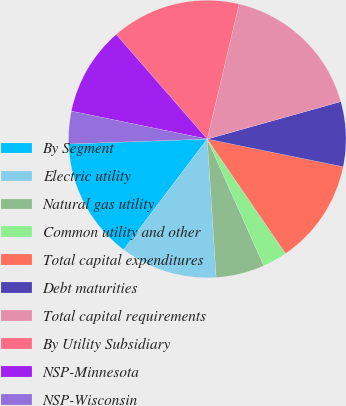Convert chart. <chart><loc_0><loc_0><loc_500><loc_500><pie_chart><fcel>By Segment<fcel>Electric utility<fcel>Natural gas utility<fcel>Common utility and other<fcel>Total capital expenditures<fcel>Debt maturities<fcel>Total capital requirements<fcel>By Utility Subsidiary<fcel>NSP-Minnesota<fcel>NSP-Wisconsin<nl><fcel>14.14%<fcel>11.32%<fcel>5.67%<fcel>2.85%<fcel>12.26%<fcel>7.55%<fcel>16.97%<fcel>15.08%<fcel>10.38%<fcel>3.79%<nl></chart> 